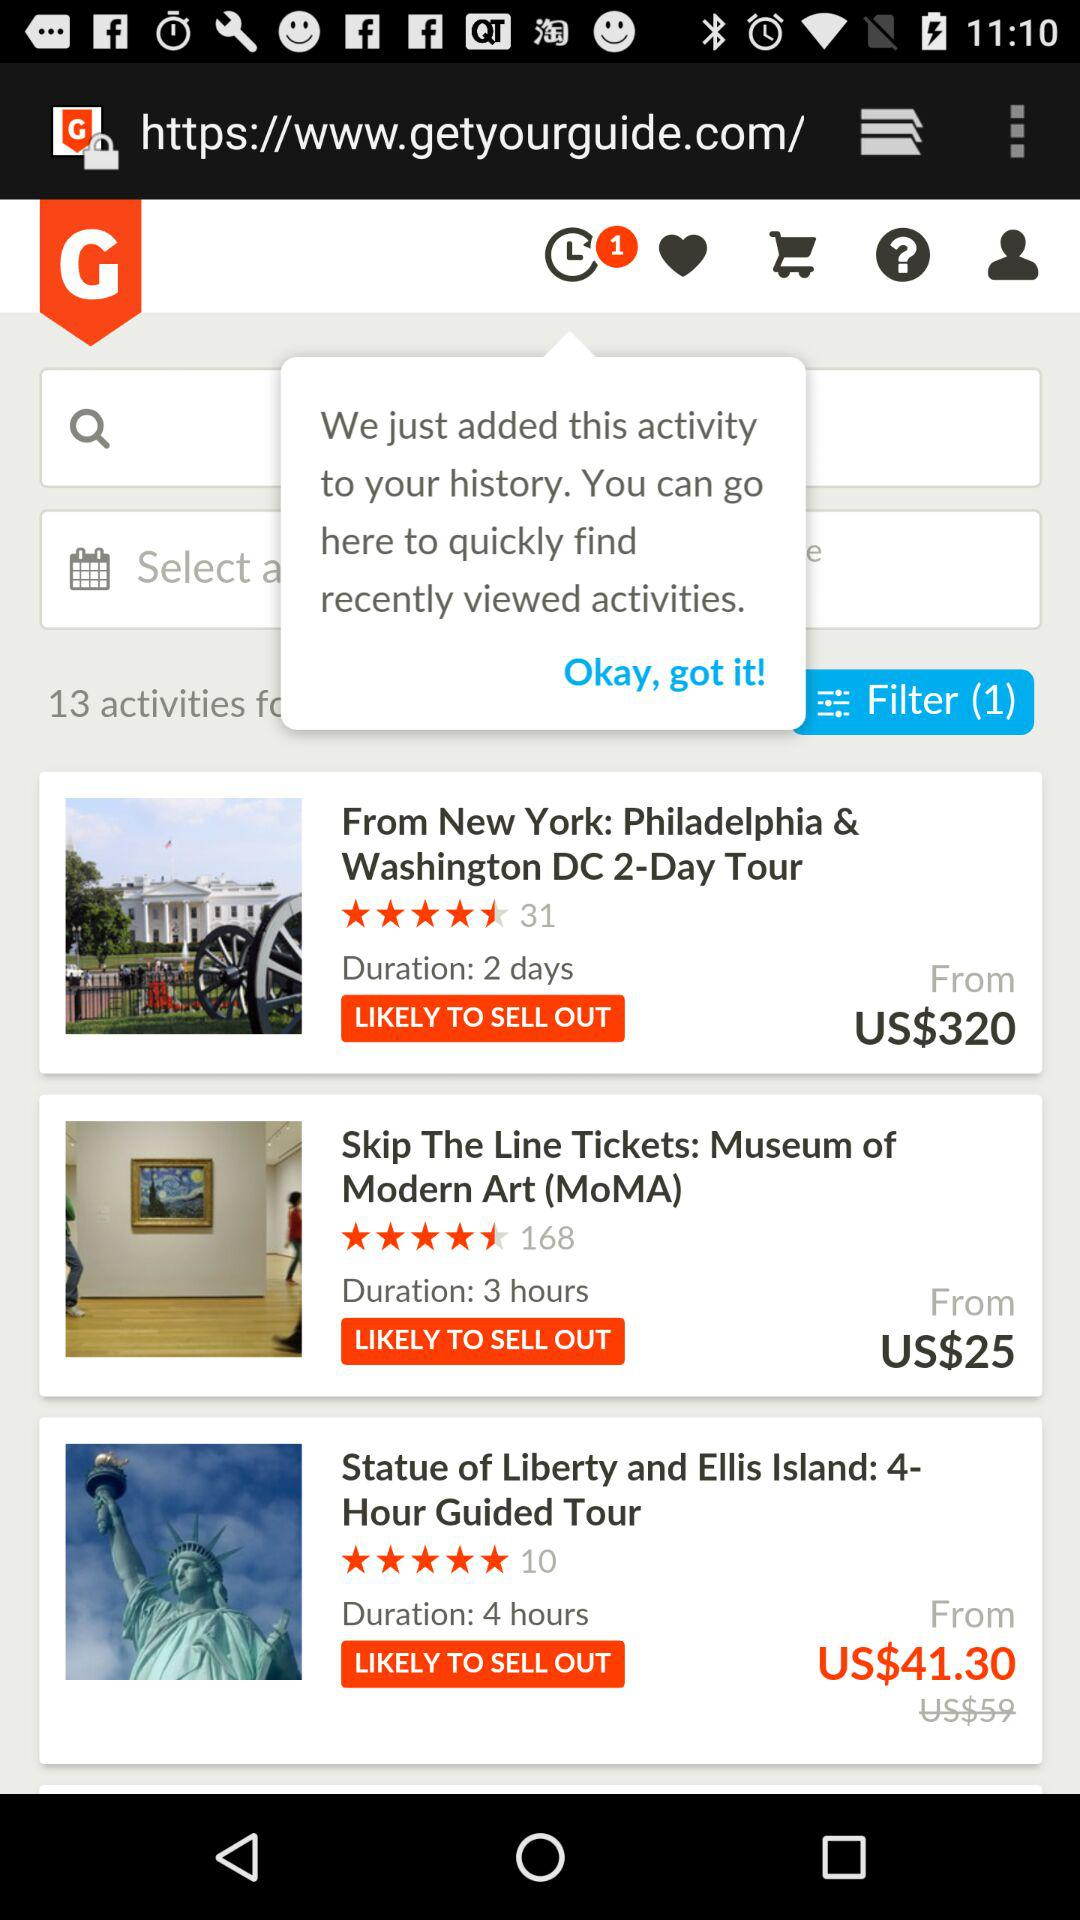How many ratings did "Philadelphia & Washington DC 2-Day Tour" get? "Philadelphia & Washington DC 2-Day Tour" got 31 ratings. 